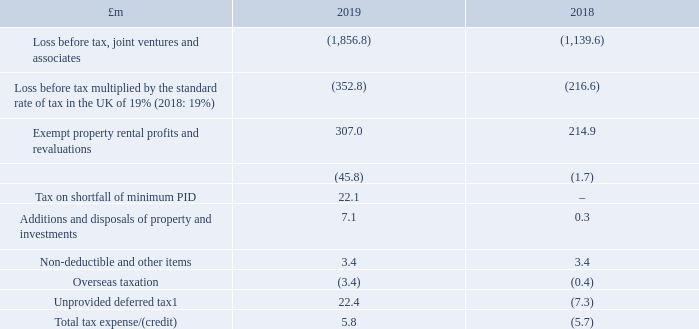10 Taxation (continued)
The tax expense for 2019 is higher and the tax credit for 2018 is lower than the standard rate of corporation tax in the UK. The differences are explained below:
1 The unprovided deferred tax predominantly relates to revenue losses, property fair values and derivative fair values.
Factors that may affect future current and total tax charges
Management uses judgement in assessing compliance with REIT legislation
The Group believes it continued to operate as a UK REIT throughout the year, under which any profits and gains from the UK property investment business are exempt from corporation tax, provided certain conditions continue to be met. The Group believes that these UK REIT conditions have been fulfilled throughout the year.
In view of the announced short-term reduction of dividends there will be an underpayment of the minimum PID, and therefore under REIT legislation, the Group will incur UK corporation tax payable at 19 per cent while remaining a REIT.
The ongoing current tax expense in the year of £16.0 million includes £15.7 million relating to corporation tax on the estimated current period underpayment of the minimum PID. This amount has been included within the Group’s measure of underlying earnings as it relates to a tax expense on current year UK rental income.
The UK exceptional current tax expense in the year of £6.4 million represents in full the corporation tax arising in the current year in respect of the prior year underpayment of the minimum PID. This one-off tax expense in respect of prior year profits has been classified as exceptional (see accounting policy in note 2) based on its incidence, and so is excluded from the Group’s measure of underlying earnings.
What does the ongoing current tax expense in the year of  £16.0 million include? Includes £15.7 million relating to corporation tax on the estimated current period underpayment of the minimum pid. What is the UK corporation tax payable incurred by the Group? 19 per cent. What does the UK exceptional current tax expense in the year of  £6.4 million represent? The corporation tax arising in the current year in respect of the prior year underpayment of the minimum pid. What is the percentage change in the loss before tax, joint ventures and associates from 2018 to 2019?
Answer scale should be: percent. (1,856.8-1,139.6)/1,139.6
Answer: 62.93. What is the percentage change in the loss before tax multiplied by the standard rate of tax in the UK of 19% from 2018 to 2019?
Answer scale should be: percent. (352.8-216.6)/216.6
Answer: 62.88. What is the percentage change in the exempt property rental profits and revaluations from 2018 to 2019?
Answer scale should be: percent. (307.0-214.9)/214.9
Answer: 42.86. 